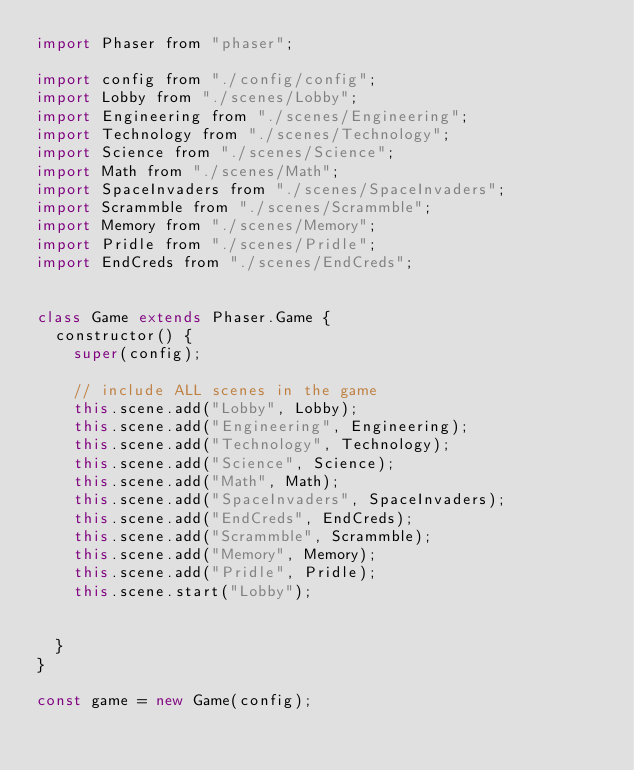<code> <loc_0><loc_0><loc_500><loc_500><_JavaScript_>import Phaser from "phaser";

import config from "./config/config";
import Lobby from "./scenes/Lobby";
import Engineering from "./scenes/Engineering";
import Technology from "./scenes/Technology";
import Science from "./scenes/Science";
import Math from "./scenes/Math";
import SpaceInvaders from "./scenes/SpaceInvaders";
import Scrammble from "./scenes/Scrammble";
import Memory from "./scenes/Memory";
import Pridle from "./scenes/Pridle";
import EndCreds from "./scenes/EndCreds";


class Game extends Phaser.Game {
  constructor() {
    super(config);

    // include ALL scenes in the game
    this.scene.add("Lobby", Lobby);
    this.scene.add("Engineering", Engineering);
    this.scene.add("Technology", Technology);
    this.scene.add("Science", Science);
    this.scene.add("Math", Math);
    this.scene.add("SpaceInvaders", SpaceInvaders);
    this.scene.add("EndCreds", EndCreds);
    this.scene.add("Scrammble", Scrammble);
    this.scene.add("Memory", Memory);
    this.scene.add("Pridle", Pridle);
    this.scene.start("Lobby");

  
  }
}

const game = new Game(config);
</code> 